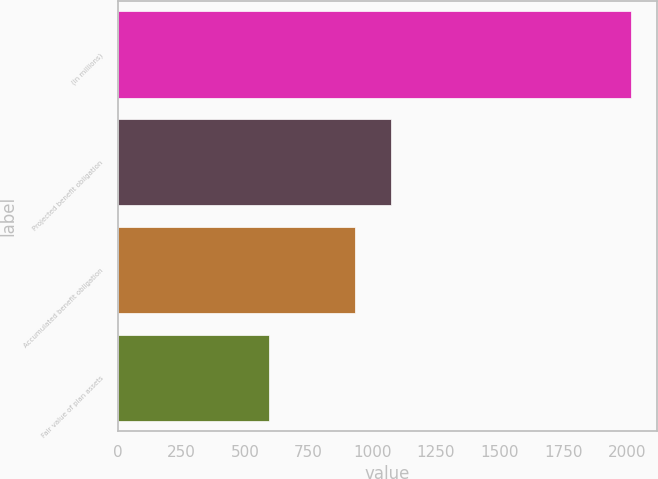Convert chart. <chart><loc_0><loc_0><loc_500><loc_500><bar_chart><fcel>(in millions)<fcel>Projected benefit obligation<fcel>Accumulated benefit obligation<fcel>Fair value of plan assets<nl><fcel>2018<fcel>1074.4<fcel>932<fcel>594<nl></chart> 